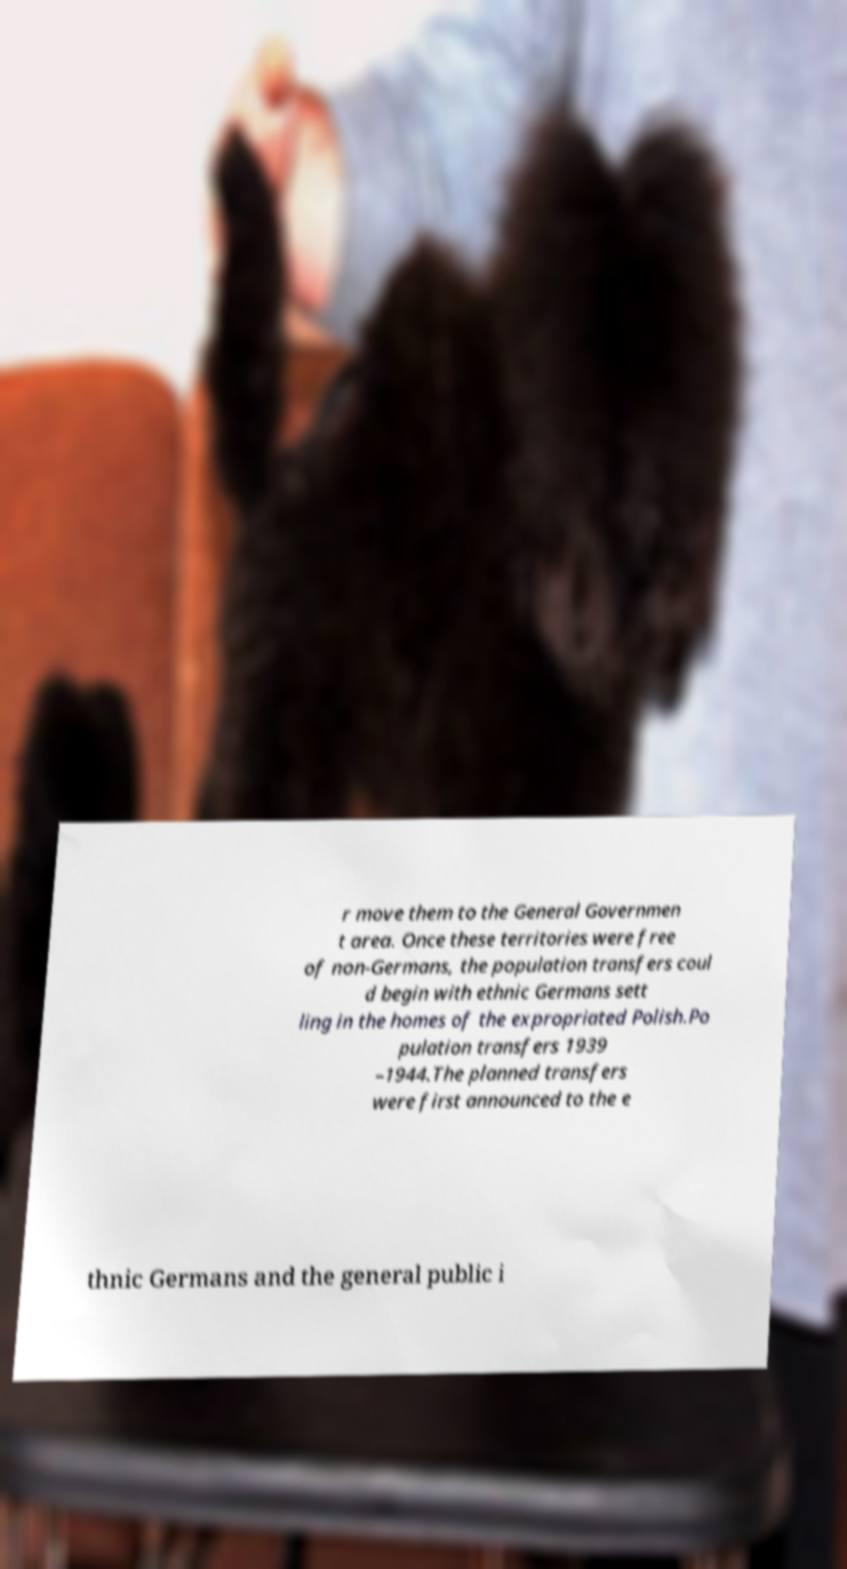Please identify and transcribe the text found in this image. r move them to the General Governmen t area. Once these territories were free of non-Germans, the population transfers coul d begin with ethnic Germans sett ling in the homes of the expropriated Polish.Po pulation transfers 1939 –1944.The planned transfers were first announced to the e thnic Germans and the general public i 